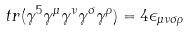<formula> <loc_0><loc_0><loc_500><loc_500>t r ( \gamma ^ { 5 } \gamma ^ { \mu } \gamma ^ { \nu } \gamma ^ { \sigma } \gamma ^ { \rho } ) = 4 \epsilon _ { \mu \nu \sigma \rho }</formula> 